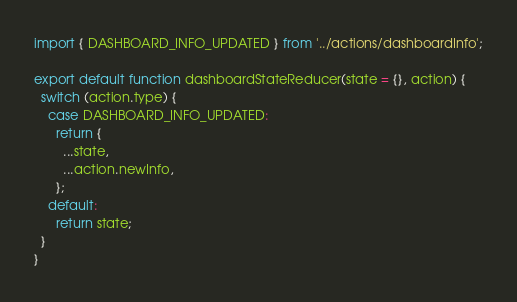<code> <loc_0><loc_0><loc_500><loc_500><_JavaScript_>
import { DASHBOARD_INFO_UPDATED } from '../actions/dashboardInfo';

export default function dashboardStateReducer(state = {}, action) {
  switch (action.type) {
    case DASHBOARD_INFO_UPDATED:
      return {
        ...state,
        ...action.newInfo,
      };
    default:
      return state;
  }
}
</code> 